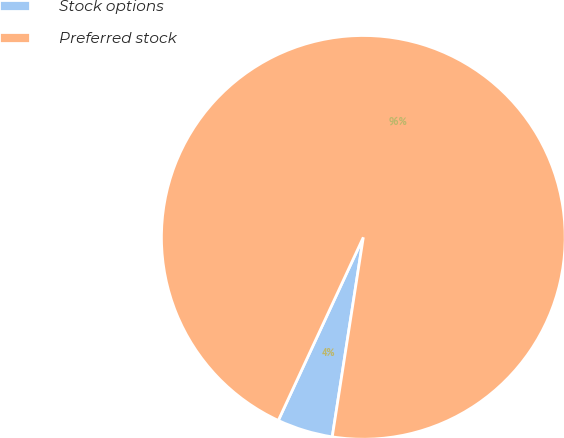Convert chart to OTSL. <chart><loc_0><loc_0><loc_500><loc_500><pie_chart><fcel>Stock options<fcel>Preferred stock<nl><fcel>4.46%<fcel>95.54%<nl></chart> 